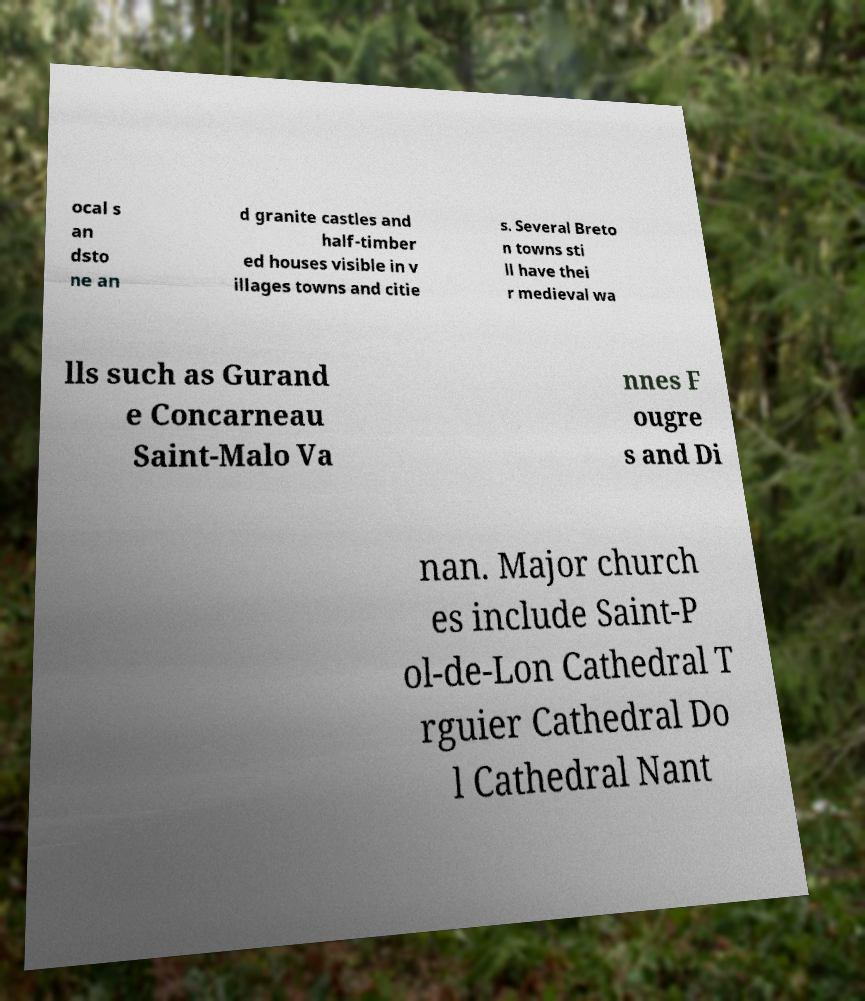Can you read and provide the text displayed in the image?This photo seems to have some interesting text. Can you extract and type it out for me? ocal s an dsto ne an d granite castles and half-timber ed houses visible in v illages towns and citie s. Several Breto n towns sti ll have thei r medieval wa lls such as Gurand e Concarneau Saint-Malo Va nnes F ougre s and Di nan. Major church es include Saint-P ol-de-Lon Cathedral T rguier Cathedral Do l Cathedral Nant 